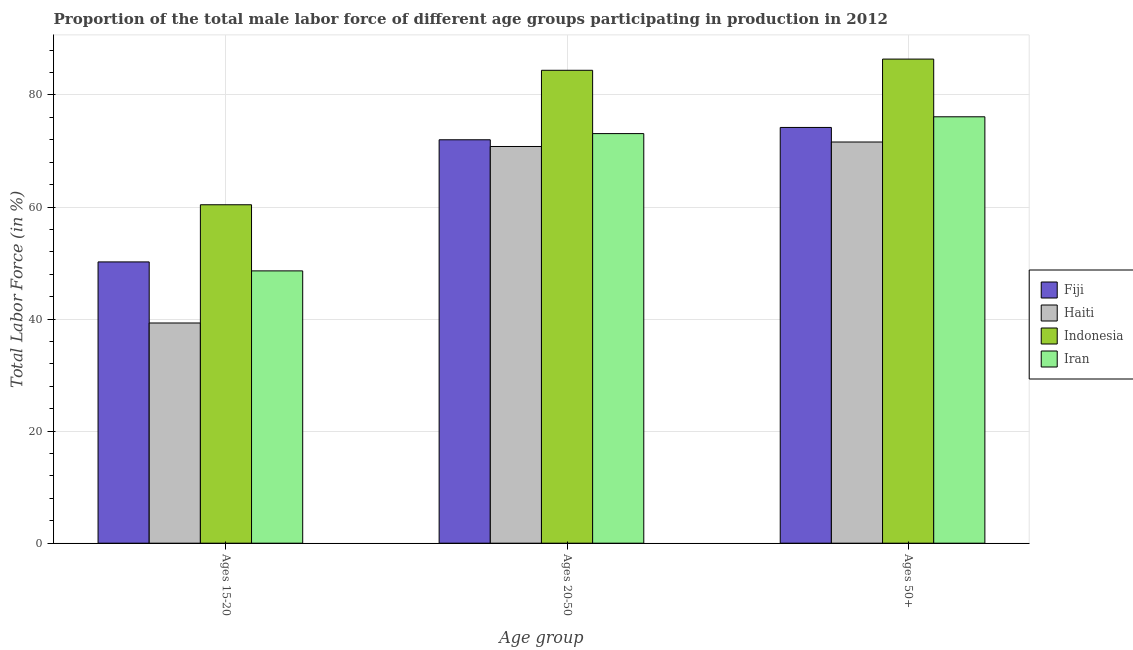How many bars are there on the 1st tick from the right?
Your answer should be compact. 4. What is the label of the 2nd group of bars from the left?
Ensure brevity in your answer.  Ages 20-50. Across all countries, what is the maximum percentage of male labor force above age 50?
Your answer should be very brief. 86.4. Across all countries, what is the minimum percentage of male labor force within the age group 15-20?
Give a very brief answer. 39.3. In which country was the percentage of male labor force within the age group 15-20 maximum?
Offer a very short reply. Indonesia. In which country was the percentage of male labor force within the age group 20-50 minimum?
Offer a terse response. Haiti. What is the total percentage of male labor force within the age group 20-50 in the graph?
Keep it short and to the point. 300.3. What is the difference between the percentage of male labor force within the age group 15-20 in Fiji and that in Iran?
Keep it short and to the point. 1.6. What is the difference between the percentage of male labor force above age 50 in Indonesia and the percentage of male labor force within the age group 20-50 in Haiti?
Your answer should be compact. 15.6. What is the average percentage of male labor force within the age group 15-20 per country?
Provide a succinct answer. 49.62. What is the difference between the percentage of male labor force within the age group 20-50 and percentage of male labor force within the age group 15-20 in Haiti?
Give a very brief answer. 31.5. In how many countries, is the percentage of male labor force within the age group 20-50 greater than 84 %?
Provide a succinct answer. 1. What is the ratio of the percentage of male labor force within the age group 15-20 in Fiji to that in Haiti?
Your answer should be very brief. 1.28. Is the difference between the percentage of male labor force within the age group 15-20 in Fiji and Indonesia greater than the difference between the percentage of male labor force above age 50 in Fiji and Indonesia?
Offer a terse response. Yes. What is the difference between the highest and the second highest percentage of male labor force within the age group 20-50?
Ensure brevity in your answer.  11.3. What is the difference between the highest and the lowest percentage of male labor force within the age group 15-20?
Ensure brevity in your answer.  21.1. What does the 1st bar from the left in Ages 20-50 represents?
Your answer should be compact. Fiji. What does the 2nd bar from the right in Ages 15-20 represents?
Make the answer very short. Indonesia. Is it the case that in every country, the sum of the percentage of male labor force within the age group 15-20 and percentage of male labor force within the age group 20-50 is greater than the percentage of male labor force above age 50?
Make the answer very short. Yes. How many bars are there?
Provide a short and direct response. 12. Are all the bars in the graph horizontal?
Your answer should be very brief. No. How many countries are there in the graph?
Your answer should be compact. 4. What is the difference between two consecutive major ticks on the Y-axis?
Offer a terse response. 20. Are the values on the major ticks of Y-axis written in scientific E-notation?
Your answer should be very brief. No. Does the graph contain any zero values?
Make the answer very short. No. Does the graph contain grids?
Your response must be concise. Yes. Where does the legend appear in the graph?
Your response must be concise. Center right. How many legend labels are there?
Provide a succinct answer. 4. How are the legend labels stacked?
Your response must be concise. Vertical. What is the title of the graph?
Offer a terse response. Proportion of the total male labor force of different age groups participating in production in 2012. What is the label or title of the X-axis?
Provide a short and direct response. Age group. What is the label or title of the Y-axis?
Your answer should be compact. Total Labor Force (in %). What is the Total Labor Force (in %) of Fiji in Ages 15-20?
Ensure brevity in your answer.  50.2. What is the Total Labor Force (in %) of Haiti in Ages 15-20?
Offer a very short reply. 39.3. What is the Total Labor Force (in %) in Indonesia in Ages 15-20?
Make the answer very short. 60.4. What is the Total Labor Force (in %) of Iran in Ages 15-20?
Ensure brevity in your answer.  48.6. What is the Total Labor Force (in %) of Haiti in Ages 20-50?
Ensure brevity in your answer.  70.8. What is the Total Labor Force (in %) in Indonesia in Ages 20-50?
Provide a short and direct response. 84.4. What is the Total Labor Force (in %) in Iran in Ages 20-50?
Give a very brief answer. 73.1. What is the Total Labor Force (in %) of Fiji in Ages 50+?
Give a very brief answer. 74.2. What is the Total Labor Force (in %) of Haiti in Ages 50+?
Keep it short and to the point. 71.6. What is the Total Labor Force (in %) of Indonesia in Ages 50+?
Your response must be concise. 86.4. What is the Total Labor Force (in %) of Iran in Ages 50+?
Ensure brevity in your answer.  76.1. Across all Age group, what is the maximum Total Labor Force (in %) of Fiji?
Your answer should be very brief. 74.2. Across all Age group, what is the maximum Total Labor Force (in %) of Haiti?
Ensure brevity in your answer.  71.6. Across all Age group, what is the maximum Total Labor Force (in %) of Indonesia?
Make the answer very short. 86.4. Across all Age group, what is the maximum Total Labor Force (in %) of Iran?
Make the answer very short. 76.1. Across all Age group, what is the minimum Total Labor Force (in %) of Fiji?
Offer a very short reply. 50.2. Across all Age group, what is the minimum Total Labor Force (in %) in Haiti?
Your answer should be very brief. 39.3. Across all Age group, what is the minimum Total Labor Force (in %) of Indonesia?
Offer a very short reply. 60.4. Across all Age group, what is the minimum Total Labor Force (in %) in Iran?
Make the answer very short. 48.6. What is the total Total Labor Force (in %) in Fiji in the graph?
Your response must be concise. 196.4. What is the total Total Labor Force (in %) of Haiti in the graph?
Offer a terse response. 181.7. What is the total Total Labor Force (in %) of Indonesia in the graph?
Ensure brevity in your answer.  231.2. What is the total Total Labor Force (in %) of Iran in the graph?
Offer a terse response. 197.8. What is the difference between the Total Labor Force (in %) in Fiji in Ages 15-20 and that in Ages 20-50?
Make the answer very short. -21.8. What is the difference between the Total Labor Force (in %) in Haiti in Ages 15-20 and that in Ages 20-50?
Make the answer very short. -31.5. What is the difference between the Total Labor Force (in %) of Iran in Ages 15-20 and that in Ages 20-50?
Your answer should be compact. -24.5. What is the difference between the Total Labor Force (in %) in Fiji in Ages 15-20 and that in Ages 50+?
Your response must be concise. -24. What is the difference between the Total Labor Force (in %) in Haiti in Ages 15-20 and that in Ages 50+?
Your response must be concise. -32.3. What is the difference between the Total Labor Force (in %) of Iran in Ages 15-20 and that in Ages 50+?
Offer a terse response. -27.5. What is the difference between the Total Labor Force (in %) of Fiji in Ages 20-50 and that in Ages 50+?
Your response must be concise. -2.2. What is the difference between the Total Labor Force (in %) in Haiti in Ages 20-50 and that in Ages 50+?
Provide a succinct answer. -0.8. What is the difference between the Total Labor Force (in %) of Indonesia in Ages 20-50 and that in Ages 50+?
Your answer should be very brief. -2. What is the difference between the Total Labor Force (in %) in Iran in Ages 20-50 and that in Ages 50+?
Ensure brevity in your answer.  -3. What is the difference between the Total Labor Force (in %) in Fiji in Ages 15-20 and the Total Labor Force (in %) in Haiti in Ages 20-50?
Ensure brevity in your answer.  -20.6. What is the difference between the Total Labor Force (in %) in Fiji in Ages 15-20 and the Total Labor Force (in %) in Indonesia in Ages 20-50?
Your response must be concise. -34.2. What is the difference between the Total Labor Force (in %) in Fiji in Ages 15-20 and the Total Labor Force (in %) in Iran in Ages 20-50?
Make the answer very short. -22.9. What is the difference between the Total Labor Force (in %) of Haiti in Ages 15-20 and the Total Labor Force (in %) of Indonesia in Ages 20-50?
Offer a terse response. -45.1. What is the difference between the Total Labor Force (in %) in Haiti in Ages 15-20 and the Total Labor Force (in %) in Iran in Ages 20-50?
Keep it short and to the point. -33.8. What is the difference between the Total Labor Force (in %) of Fiji in Ages 15-20 and the Total Labor Force (in %) of Haiti in Ages 50+?
Offer a very short reply. -21.4. What is the difference between the Total Labor Force (in %) in Fiji in Ages 15-20 and the Total Labor Force (in %) in Indonesia in Ages 50+?
Ensure brevity in your answer.  -36.2. What is the difference between the Total Labor Force (in %) of Fiji in Ages 15-20 and the Total Labor Force (in %) of Iran in Ages 50+?
Your answer should be very brief. -25.9. What is the difference between the Total Labor Force (in %) in Haiti in Ages 15-20 and the Total Labor Force (in %) in Indonesia in Ages 50+?
Offer a very short reply. -47.1. What is the difference between the Total Labor Force (in %) of Haiti in Ages 15-20 and the Total Labor Force (in %) of Iran in Ages 50+?
Your answer should be very brief. -36.8. What is the difference between the Total Labor Force (in %) of Indonesia in Ages 15-20 and the Total Labor Force (in %) of Iran in Ages 50+?
Offer a terse response. -15.7. What is the difference between the Total Labor Force (in %) in Fiji in Ages 20-50 and the Total Labor Force (in %) in Haiti in Ages 50+?
Your answer should be compact. 0.4. What is the difference between the Total Labor Force (in %) in Fiji in Ages 20-50 and the Total Labor Force (in %) in Indonesia in Ages 50+?
Your answer should be compact. -14.4. What is the difference between the Total Labor Force (in %) in Fiji in Ages 20-50 and the Total Labor Force (in %) in Iran in Ages 50+?
Make the answer very short. -4.1. What is the difference between the Total Labor Force (in %) in Haiti in Ages 20-50 and the Total Labor Force (in %) in Indonesia in Ages 50+?
Provide a short and direct response. -15.6. What is the average Total Labor Force (in %) in Fiji per Age group?
Provide a succinct answer. 65.47. What is the average Total Labor Force (in %) of Haiti per Age group?
Your answer should be compact. 60.57. What is the average Total Labor Force (in %) of Indonesia per Age group?
Ensure brevity in your answer.  77.07. What is the average Total Labor Force (in %) of Iran per Age group?
Provide a succinct answer. 65.93. What is the difference between the Total Labor Force (in %) of Fiji and Total Labor Force (in %) of Haiti in Ages 15-20?
Your response must be concise. 10.9. What is the difference between the Total Labor Force (in %) in Fiji and Total Labor Force (in %) in Iran in Ages 15-20?
Keep it short and to the point. 1.6. What is the difference between the Total Labor Force (in %) of Haiti and Total Labor Force (in %) of Indonesia in Ages 15-20?
Offer a very short reply. -21.1. What is the difference between the Total Labor Force (in %) in Fiji and Total Labor Force (in %) in Indonesia in Ages 20-50?
Keep it short and to the point. -12.4. What is the difference between the Total Labor Force (in %) of Fiji and Total Labor Force (in %) of Haiti in Ages 50+?
Provide a short and direct response. 2.6. What is the difference between the Total Labor Force (in %) of Fiji and Total Labor Force (in %) of Indonesia in Ages 50+?
Your answer should be very brief. -12.2. What is the difference between the Total Labor Force (in %) in Fiji and Total Labor Force (in %) in Iran in Ages 50+?
Give a very brief answer. -1.9. What is the difference between the Total Labor Force (in %) of Haiti and Total Labor Force (in %) of Indonesia in Ages 50+?
Your answer should be compact. -14.8. What is the difference between the Total Labor Force (in %) of Haiti and Total Labor Force (in %) of Iran in Ages 50+?
Provide a succinct answer. -4.5. What is the ratio of the Total Labor Force (in %) in Fiji in Ages 15-20 to that in Ages 20-50?
Your answer should be very brief. 0.7. What is the ratio of the Total Labor Force (in %) in Haiti in Ages 15-20 to that in Ages 20-50?
Provide a short and direct response. 0.56. What is the ratio of the Total Labor Force (in %) in Indonesia in Ages 15-20 to that in Ages 20-50?
Your answer should be compact. 0.72. What is the ratio of the Total Labor Force (in %) in Iran in Ages 15-20 to that in Ages 20-50?
Ensure brevity in your answer.  0.66. What is the ratio of the Total Labor Force (in %) in Fiji in Ages 15-20 to that in Ages 50+?
Keep it short and to the point. 0.68. What is the ratio of the Total Labor Force (in %) in Haiti in Ages 15-20 to that in Ages 50+?
Make the answer very short. 0.55. What is the ratio of the Total Labor Force (in %) of Indonesia in Ages 15-20 to that in Ages 50+?
Make the answer very short. 0.7. What is the ratio of the Total Labor Force (in %) in Iran in Ages 15-20 to that in Ages 50+?
Provide a short and direct response. 0.64. What is the ratio of the Total Labor Force (in %) of Fiji in Ages 20-50 to that in Ages 50+?
Your response must be concise. 0.97. What is the ratio of the Total Labor Force (in %) in Haiti in Ages 20-50 to that in Ages 50+?
Provide a short and direct response. 0.99. What is the ratio of the Total Labor Force (in %) in Indonesia in Ages 20-50 to that in Ages 50+?
Provide a short and direct response. 0.98. What is the ratio of the Total Labor Force (in %) in Iran in Ages 20-50 to that in Ages 50+?
Ensure brevity in your answer.  0.96. What is the difference between the highest and the second highest Total Labor Force (in %) in Fiji?
Keep it short and to the point. 2.2. What is the difference between the highest and the second highest Total Labor Force (in %) in Haiti?
Provide a succinct answer. 0.8. What is the difference between the highest and the second highest Total Labor Force (in %) in Iran?
Offer a terse response. 3. What is the difference between the highest and the lowest Total Labor Force (in %) in Fiji?
Provide a succinct answer. 24. What is the difference between the highest and the lowest Total Labor Force (in %) in Haiti?
Offer a terse response. 32.3. What is the difference between the highest and the lowest Total Labor Force (in %) in Iran?
Your response must be concise. 27.5. 